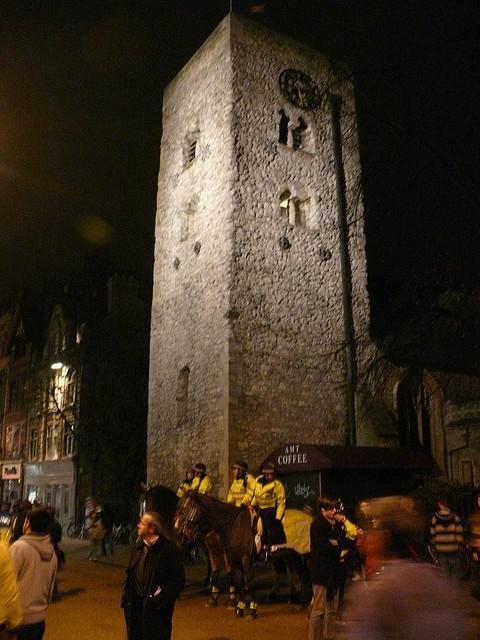How many police are on horseback?
Give a very brief answer. 4. How many people are visible?
Give a very brief answer. 5. How many elephants are walking down the street?
Give a very brief answer. 0. 